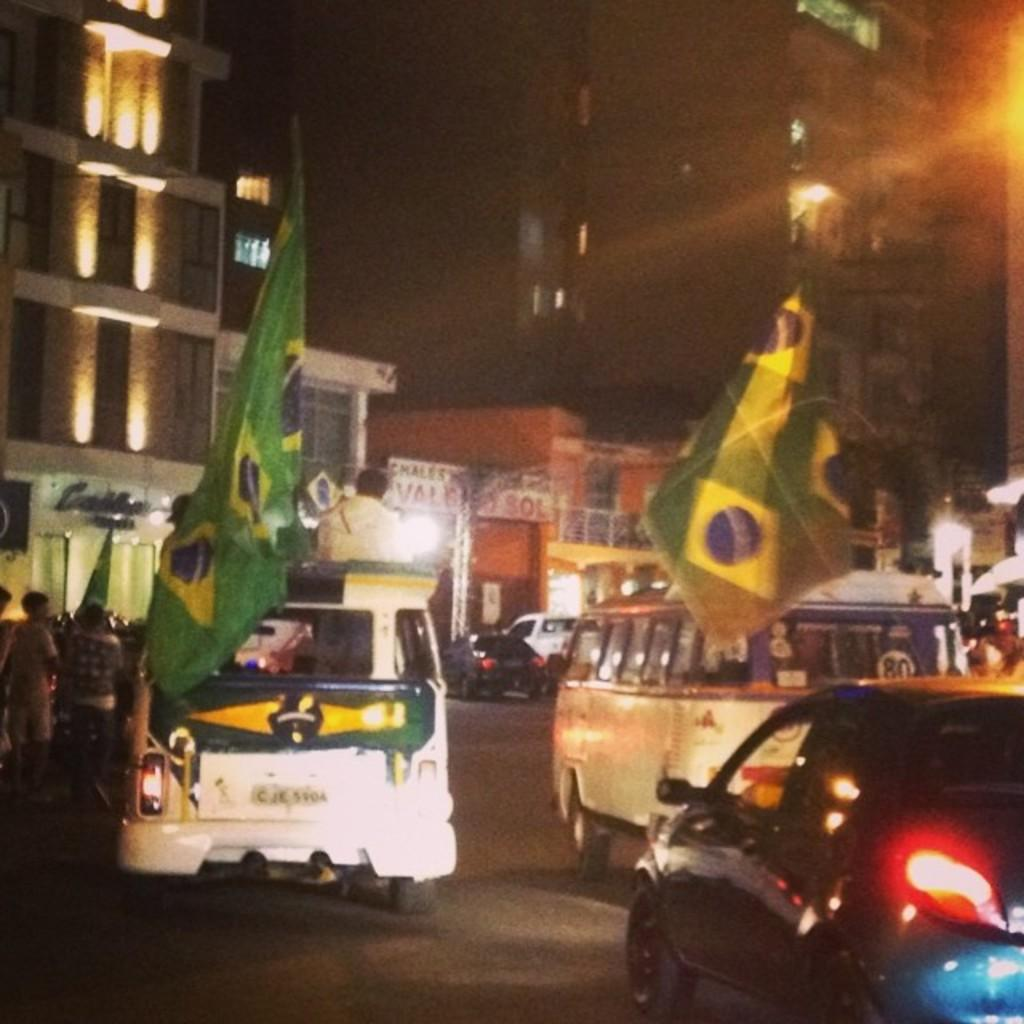Provide a one-sentence caption for the provided image. CJK 5904 is displayed on the rear license plate of the van. 